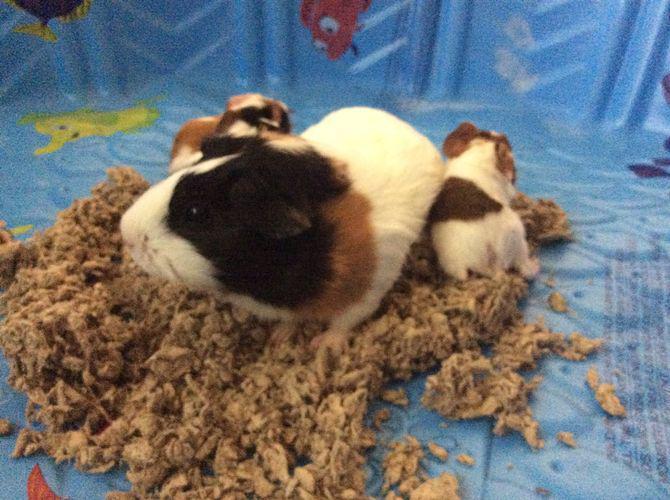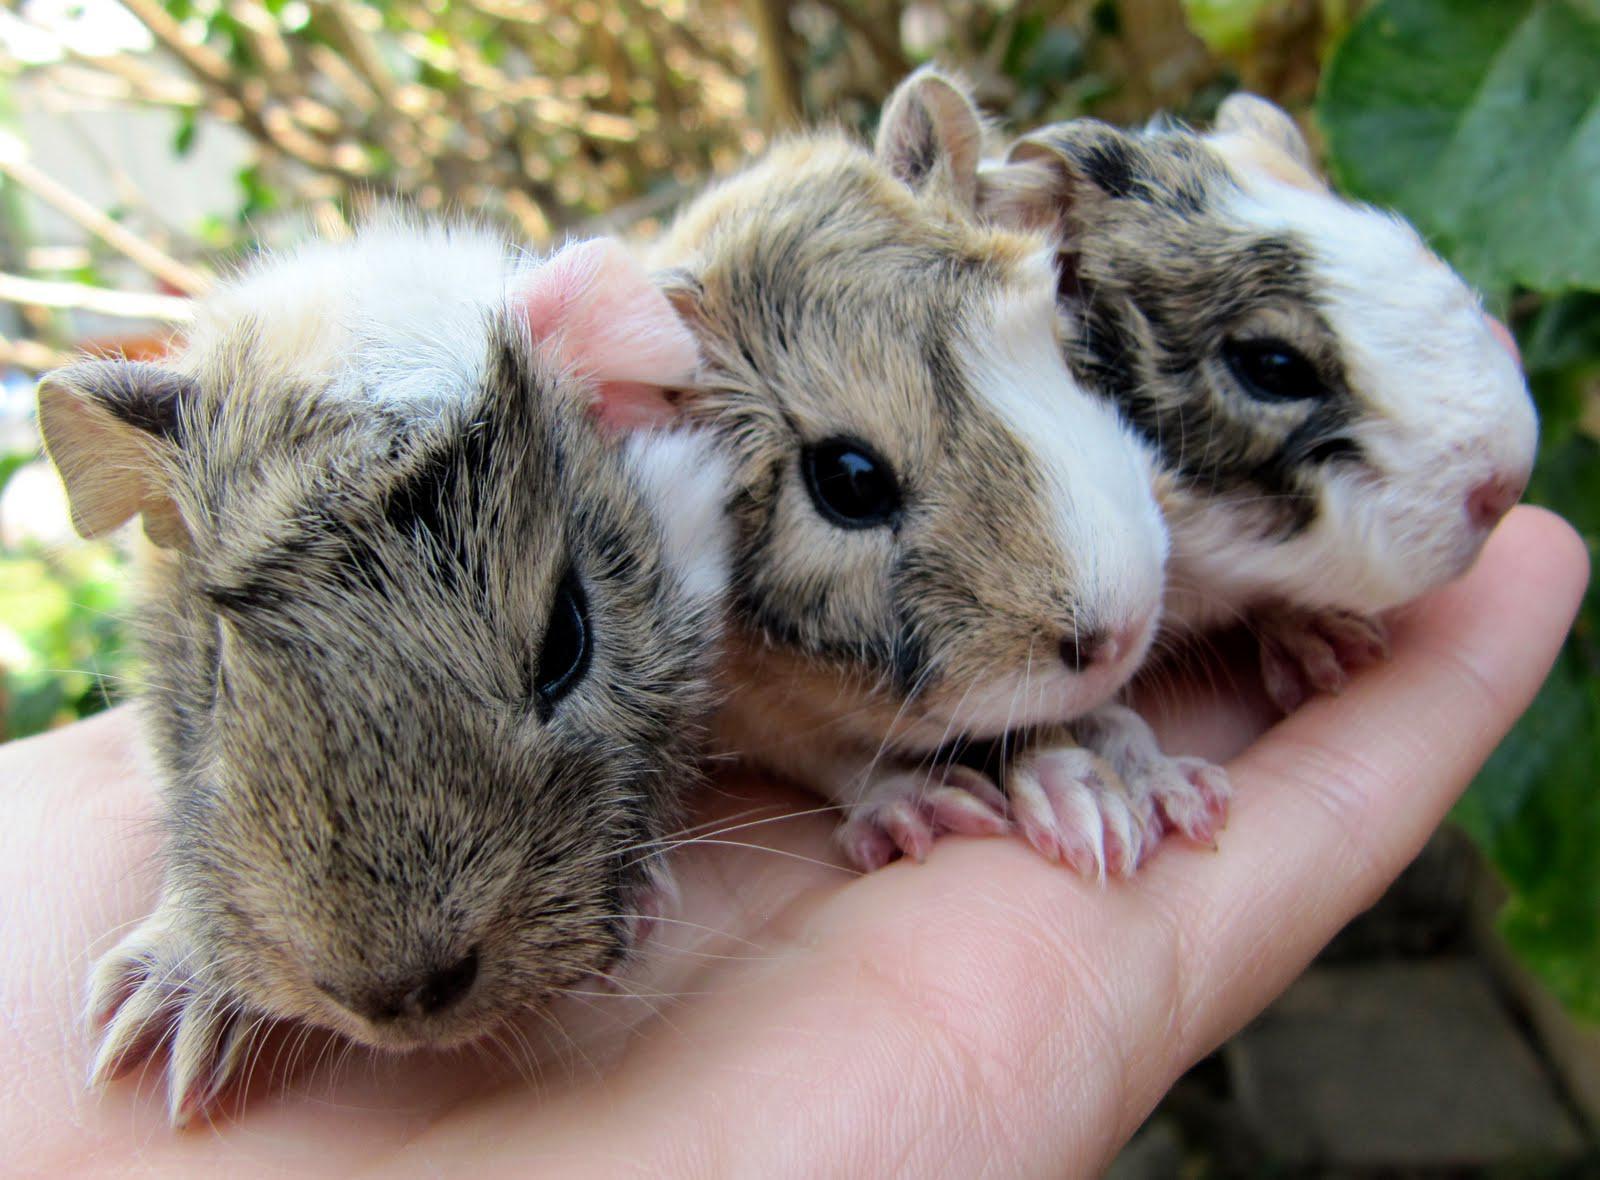The first image is the image on the left, the second image is the image on the right. For the images displayed, is the sentence "In one image, three gerbils are being held in one or more human hands that have the palm up and fingers extended." factually correct? Answer yes or no. Yes. The first image is the image on the left, the second image is the image on the right. Analyze the images presented: Is the assertion "Three hamsters are held in human hands in one image." valid? Answer yes or no. Yes. 